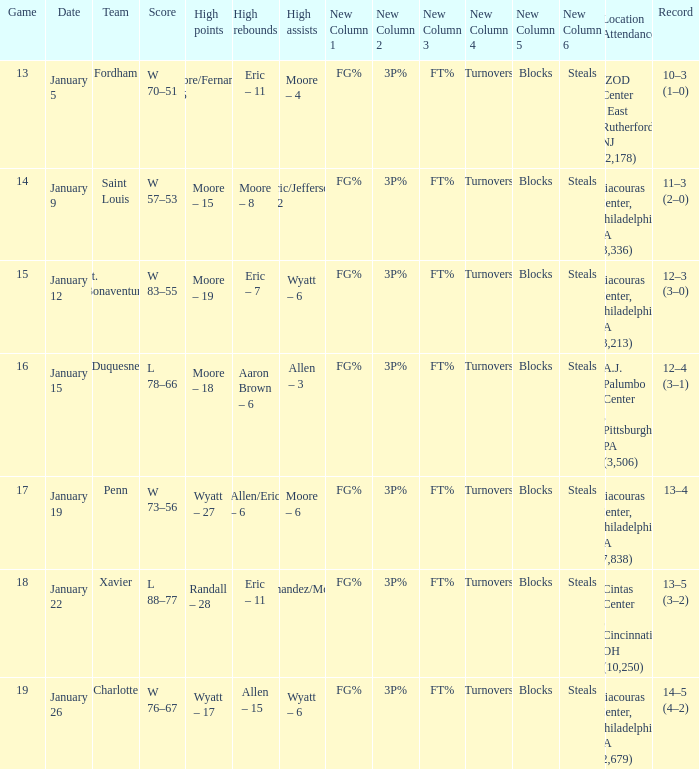What team was Temple playing on January 19? Penn. Would you mind parsing the complete table? {'header': ['Game', 'Date', 'Team', 'Score', 'High points', 'High rebounds', 'High assists', 'New Column 1', 'New Column 2', 'New Column 3', 'New Column 4', 'New Column 5', 'New Column 6', 'Location Attendance', 'Record'], 'rows': [['13', 'January 5', 'Fordham', 'W 70–51', 'Moore/Fernandez – 15', 'Eric – 11', 'Moore – 4', 'FG%', '3P%', 'FT%', 'Turnovers', 'Blocks', 'Steals', 'IZOD Center , East Rutherford, NJ (2,178)', '10–3 (1–0)'], ['14', 'January 9', 'Saint Louis', 'W 57–53', 'Moore – 15', 'Moore – 8', 'Eric/Jefferson – 2', 'FG%', '3P%', 'FT%', 'Turnovers', 'Blocks', 'Steals', 'Liacouras Center, Philadelphia, PA (3,336)', '11–3 (2–0)'], ['15', 'January 12', 'St. Bonaventure', 'W 83–55', 'Moore – 19', 'Eric – 7', 'Wyatt – 6', 'FG%', '3P%', 'FT%', 'Turnovers', 'Blocks', 'Steals', 'Liacouras Center, Philadelphia, PA (3,213)', '12–3 (3–0)'], ['16', 'January 15', 'Duquesne', 'L 78–66', 'Moore – 18', 'Aaron Brown – 6', 'Allen – 3', 'FG%', '3P%', 'FT%', 'Turnovers', 'Blocks', 'Steals', 'A.J. Palumbo Center , Pittsburgh, PA (3,506)', '12–4 (3–1)'], ['17', 'January 19', 'Penn', 'W 73–56', 'Wyatt – 27', 'Allen/Eric – 6', 'Moore – 6', 'FG%', '3P%', 'FT%', 'Turnovers', 'Blocks', 'Steals', 'Liacouras Center, Philadelphia, PA (7,838)', '13–4'], ['18', 'January 22', 'Xavier', 'L 88–77', 'Randall – 28', 'Eric – 11', 'Fernandez/Moore – 5', 'FG%', '3P%', 'FT%', 'Turnovers', 'Blocks', 'Steals', 'Cintas Center , Cincinnati, OH (10,250)', '13–5 (3–2)'], ['19', 'January 26', 'Charlotte', 'W 76–67', 'Wyatt – 17', 'Allen – 15', 'Wyatt – 6', 'FG%', '3P%', 'FT%', 'Turnovers', 'Blocks', 'Steals', 'Liacouras Center, Philadelphia, PA (2,679)', '14–5 (4–2)']]} 